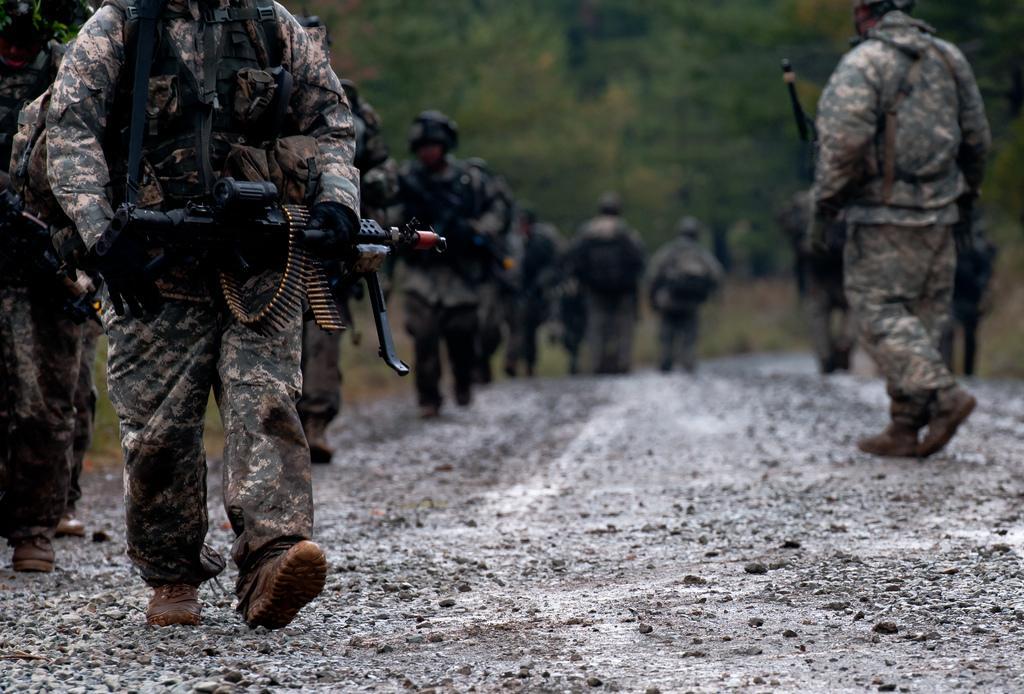Can you describe this image briefly? In this image I can see a path in the centre and on it I can see number of people. I can see all of them are wearing uniforms, shoes and few of them are holding guns. In the background I can see grass ground, number of trees and I can also see this image is little bit blurry. 